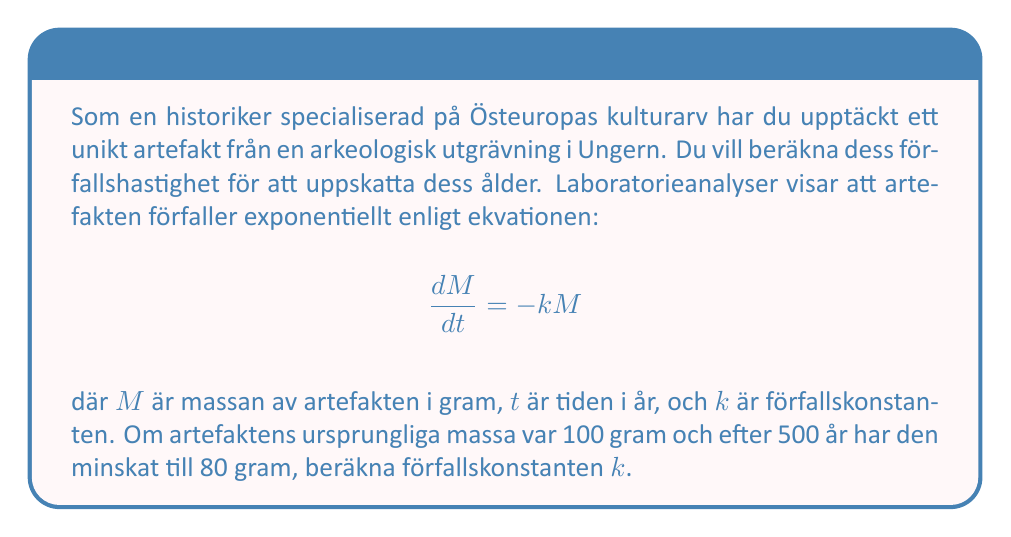Could you help me with this problem? För att lösa detta problem, följ dessa steg:

1) Den allmänna lösningen för den givna differentialekvationen är:

   $$M(t) = M_0e^{-kt}$$

   där $M_0$ är den ursprungliga massan.

2) Vi vet att:
   $M_0 = 100$ gram
   $M(500) = 80$ gram
   $t = 500$ år

3) Sätt in dessa värden i ekvationen:

   $$80 = 100e^{-500k}$$

4) Dividera båda sidor med 100:

   $$0.8 = e^{-500k}$$

5) Ta naturliga logaritmen av båda sidor:

   $$\ln(0.8) = -500k$$

6) Lös för $k$:

   $$k = -\frac{\ln(0.8)}{500}$$

7) Beräkna värdet:

   $$k = -\frac{\ln(0.8)}{500} \approx 0.000446$$

Därmed är förfallskonstanten $k \approx 0.000446$ per år.
Answer: $k \approx 0.000446$ år$^{-1}$ 